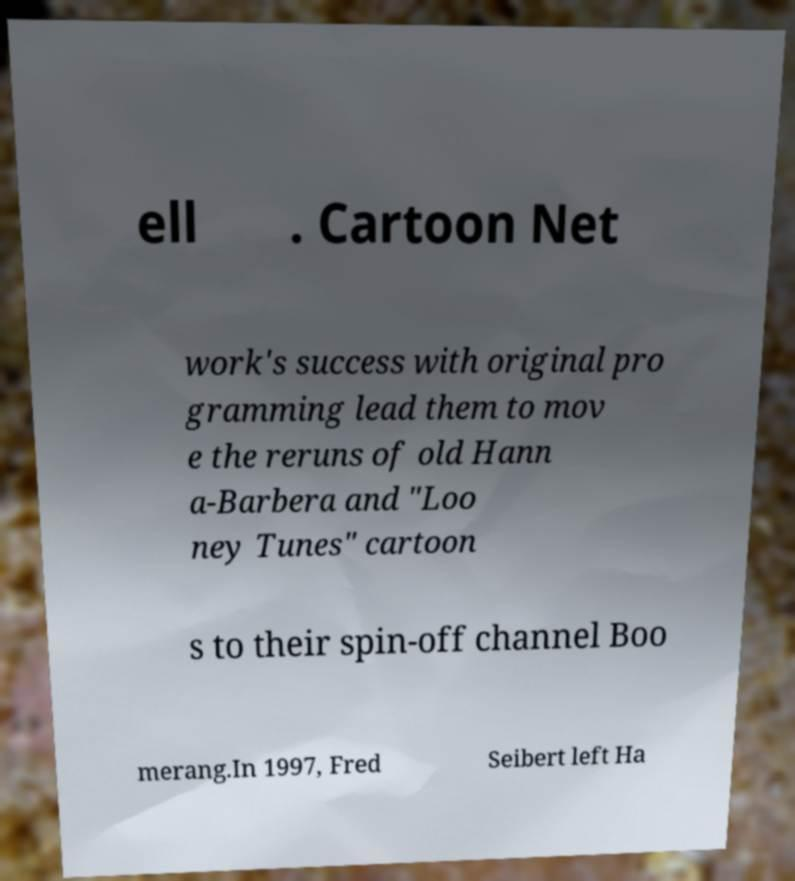Please read and relay the text visible in this image. What does it say? ell . Cartoon Net work's success with original pro gramming lead them to mov e the reruns of old Hann a-Barbera and "Loo ney Tunes" cartoon s to their spin-off channel Boo merang.In 1997, Fred Seibert left Ha 